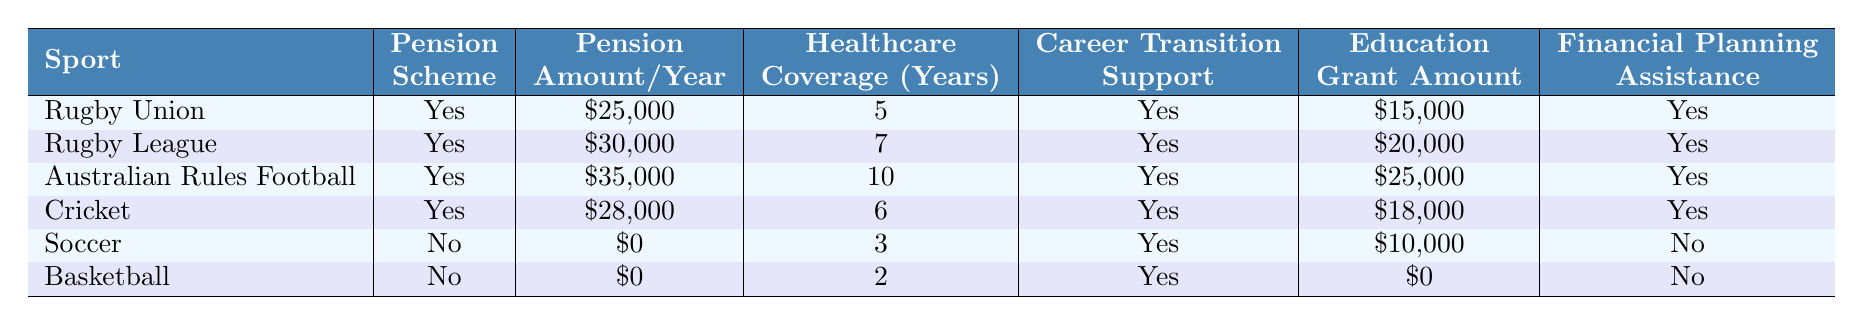What retirement benefits does Rugby Union offer? Rugby Union provides a pension scheme, healthcare coverage for 5 years, career transition support, education grants of $15,000, mental health services, and financial planning assistance.
Answer: Rugby Union offers multiple benefits including a pension, healthcare, career support, education grants, mental health services, and financial planning assistance How many years of healthcare coverage does Rugby League provide? According to the table, Rugby League provides healthcare coverage for 7 years.
Answer: 7 years Which sport has the highest pension amount per year? By comparing the pension amounts in the table, Australian Rules Football has the highest pension amount at $35,000.
Answer: Australian Rules Football Does Soccer have a pension scheme? The table indicates that Soccer does not have a pension scheme as it states "No" under the pension scheme column.
Answer: No What is the total amount of education grants available for Rugby Union and Cricket combined? Rugby Union provides $15,000 and Cricket provides $18,000 in education grants. Adding these amounts gives $15,000 + $18,000 = $33,000 in total.
Answer: $33,000 Which sport has the least amount of healthcare coverage years? Looking at the healthcare coverage years for each sport, Basketball has the least at 2 years.
Answer: Basketball Is there any sport that offers financial planning assistance? The table shows that Rugby Union, Rugby League, Australian Rules Football, Cricket, and Soccer offer financial planning assistance, while Basketball does not.
Answer: Yes What is the average pension amount across all the sports listed? Adding up all the pension amounts gives $25,000 (Rugby Union) + $30,000 (Rugby League) + $35,000 (Australian Rules) + $28,000 (Cricket) + $0 (Soccer) + $0 (Basketball) = $118,000. There are 6 sports, so the average is $118,000 / 6 = $19,666.67.
Answer: $19,666.67 What benefits does the Rugby League notable retirement program provide? The NRL Players' Trust provides financial assistance to former players facing hardship, according to the information in the table.
Answer: Financial assistance for hardship Does Cricket have a greater pension amount than Soccer? Yes, Cricket's pension amount is $28,000, while Soccer has none ($0), making Cricket's pension greater.
Answer: Yes 